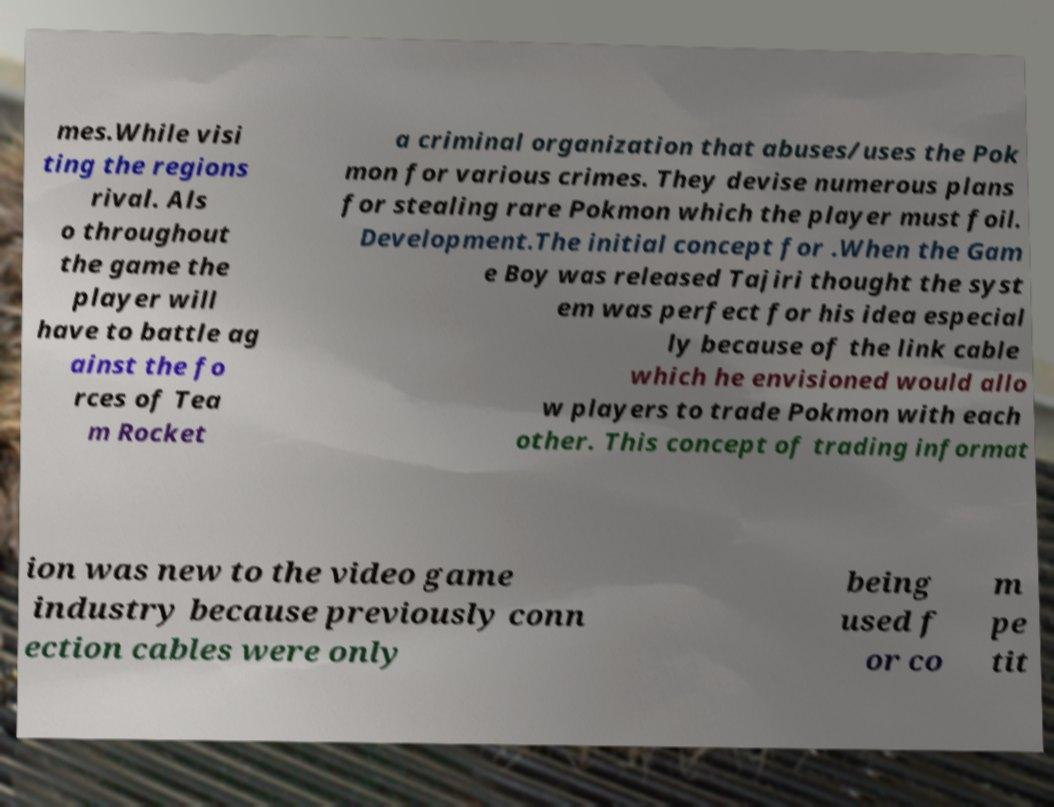Please identify and transcribe the text found in this image. mes.While visi ting the regions rival. Als o throughout the game the player will have to battle ag ainst the fo rces of Tea m Rocket a criminal organization that abuses/uses the Pok mon for various crimes. They devise numerous plans for stealing rare Pokmon which the player must foil. Development.The initial concept for .When the Gam e Boy was released Tajiri thought the syst em was perfect for his idea especial ly because of the link cable which he envisioned would allo w players to trade Pokmon with each other. This concept of trading informat ion was new to the video game industry because previously conn ection cables were only being used f or co m pe tit 